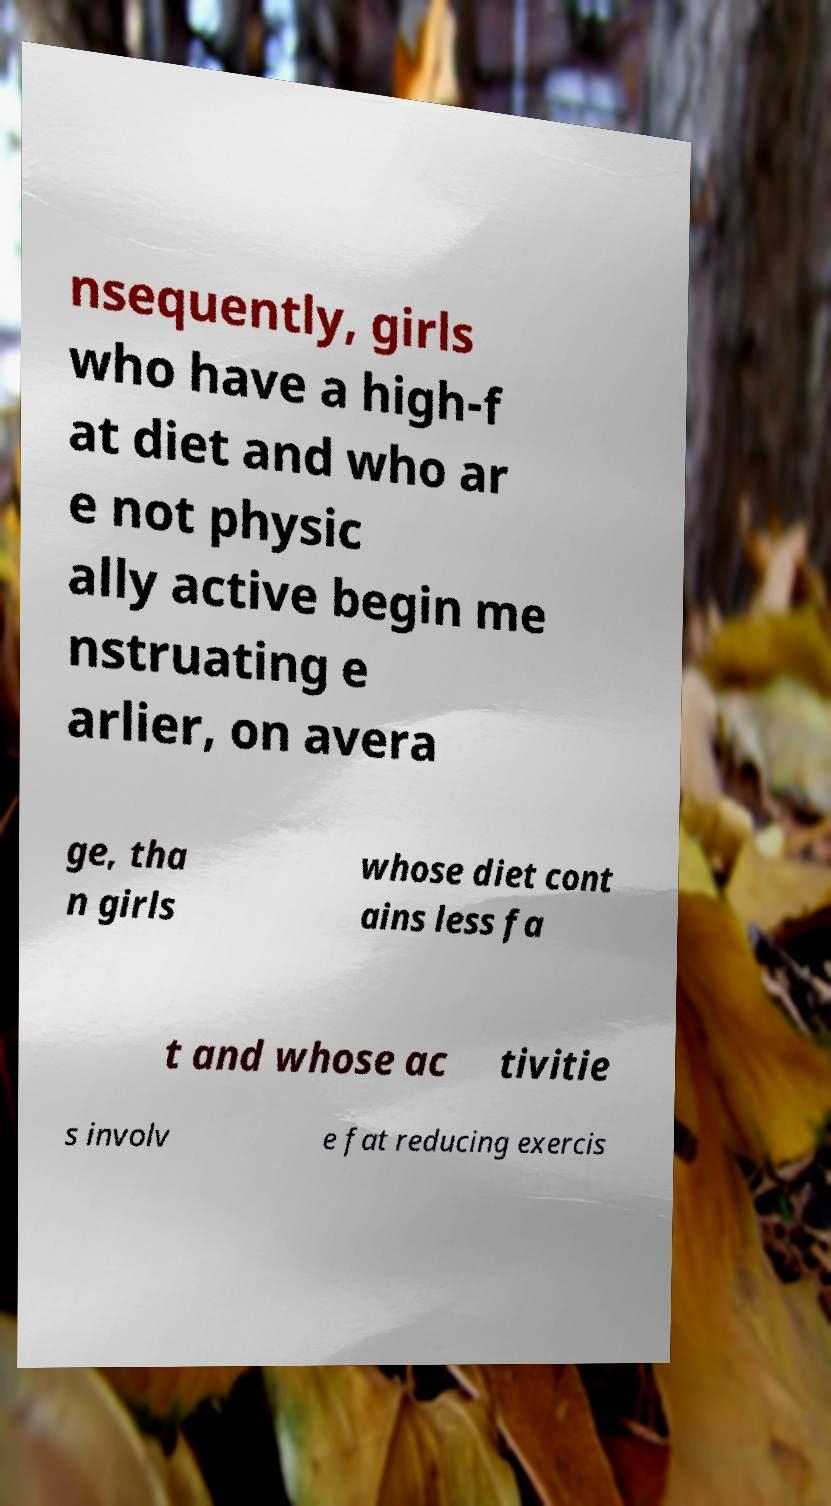There's text embedded in this image that I need extracted. Can you transcribe it verbatim? nsequently, girls who have a high-f at diet and who ar e not physic ally active begin me nstruating e arlier, on avera ge, tha n girls whose diet cont ains less fa t and whose ac tivitie s involv e fat reducing exercis 